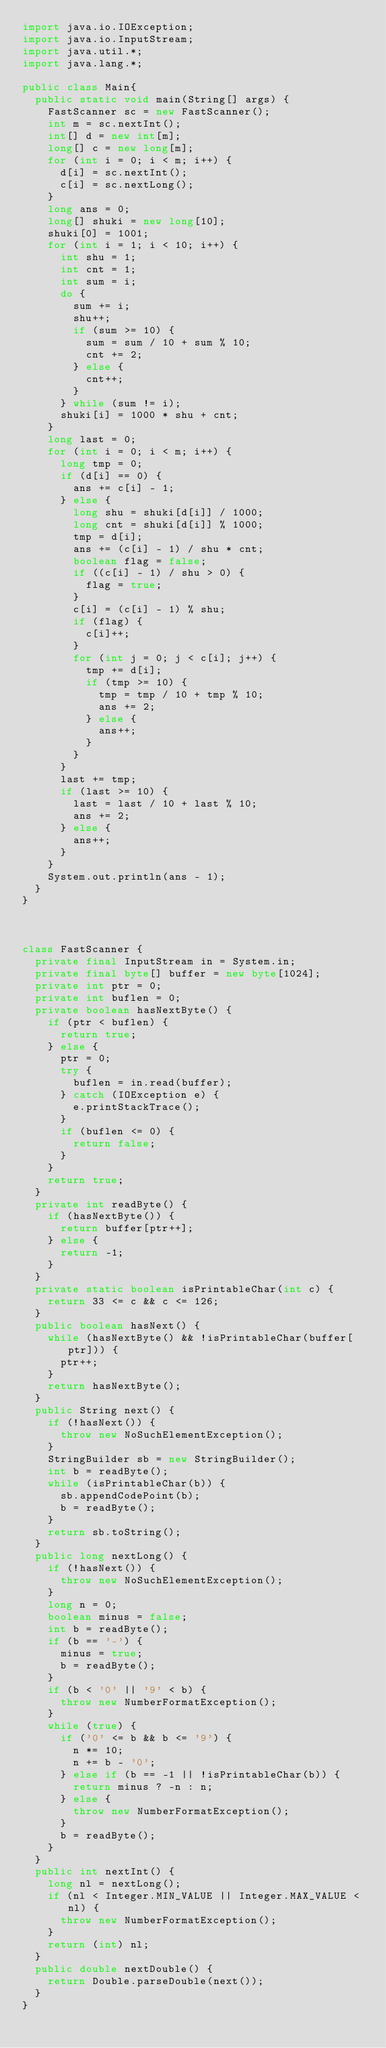<code> <loc_0><loc_0><loc_500><loc_500><_Java_>import java.io.IOException;
import java.io.InputStream;
import java.util.*;
import java.lang.*;

public class Main{
	public static void main(String[] args) {
		FastScanner sc = new FastScanner();
		int m = sc.nextInt();
		int[] d = new int[m];
		long[] c = new long[m];
		for (int i = 0; i < m; i++) {
			d[i] = sc.nextInt();
			c[i] = sc.nextLong();
		}
		long ans = 0;
		long[] shuki = new long[10];
		shuki[0] = 1001;
		for (int i = 1; i < 10; i++) {
			int shu = 1;
			int cnt = 1;
			int sum = i;
			do {
				sum += i;
				shu++;
				if (sum >= 10) {
					sum = sum / 10 + sum % 10;
					cnt += 2;
				} else {
					cnt++;
				}
			} while (sum != i);
			shuki[i] = 1000 * shu + cnt;
		}
		long last = 0;
		for (int i = 0; i < m; i++) {
			long tmp = 0;
			if (d[i] == 0) {
				ans += c[i] - 1;
			} else {
				long shu = shuki[d[i]] / 1000;
				long cnt = shuki[d[i]] % 1000;
				tmp = d[i];
				ans += (c[i] - 1) / shu * cnt;
				boolean flag = false;
				if ((c[i] - 1) / shu > 0) {
					flag = true;
				}
				c[i] = (c[i] - 1) % shu;
				if (flag) {
					c[i]++;
				}
				for (int j = 0; j < c[i]; j++) {
					tmp += d[i];
					if (tmp >= 10) {
						tmp = tmp / 10 + tmp % 10;
						ans += 2;
					} else {
						ans++;
					}
				}
			}
			last += tmp;
			if (last >= 10) {
				last = last / 10 + last % 10;
				ans += 2;
			} else {
				ans++;
			}
		}
		System.out.println(ans - 1);
	}
}



class FastScanner {
	private final InputStream in = System.in;
	private final byte[] buffer = new byte[1024];
	private int ptr = 0;
	private int buflen = 0;
	private boolean hasNextByte() {
		if (ptr < buflen) {
			return true;
		} else {
			ptr = 0;
			try {
				buflen = in.read(buffer);
			} catch (IOException e) {
				e.printStackTrace();
			}
			if (buflen <= 0) {
				return false;
			}
		}
		return true;
	}
	private int readByte() {
		if (hasNextByte()) {
			return buffer[ptr++];
		} else {
			return -1;
		}
	}
	private static boolean isPrintableChar(int c) {
		return 33 <= c && c <= 126;
	}
	public boolean hasNext() {
		while (hasNextByte() && !isPrintableChar(buffer[ptr])) {
			ptr++;
		}
		return hasNextByte();
	}
	public String next() {
		if (!hasNext()) {
			throw new NoSuchElementException();
		}
		StringBuilder sb = new StringBuilder();
		int b = readByte();
		while (isPrintableChar(b)) {
			sb.appendCodePoint(b);
			b = readByte();
		}
		return sb.toString();
	}
	public long nextLong() {
		if (!hasNext()) {
			throw new NoSuchElementException();
		}
		long n = 0;
		boolean minus = false;
		int b = readByte();
		if (b == '-') {
			minus = true;
			b = readByte();
		}
		if (b < '0' || '9' < b) {
			throw new NumberFormatException();
		}
		while (true) {
			if ('0' <= b && b <= '9') {
				n *= 10;
				n += b - '0';
			} else if (b == -1 || !isPrintableChar(b)) {
				return minus ? -n : n;
			} else {
				throw new NumberFormatException();
			}
			b = readByte();
		}
	}
	public int nextInt() {
		long nl = nextLong();
		if (nl < Integer.MIN_VALUE || Integer.MAX_VALUE < nl) {
			throw new NumberFormatException();
		}
		return (int) nl;
	}
	public double nextDouble() {
		return Double.parseDouble(next());
	}
}
</code> 